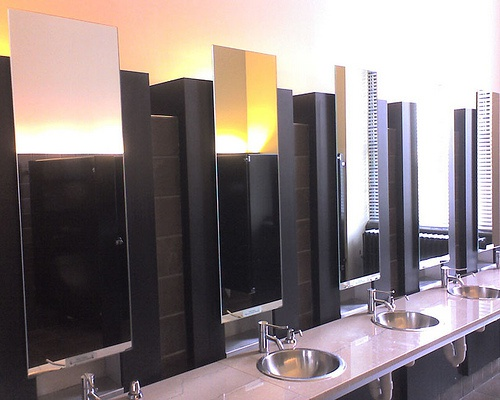Describe the objects in this image and their specific colors. I can see sink in tan, gray, lavender, and darkgray tones, sink in tan, darkgray, white, and gray tones, and sink in tan, lavender, darkgray, and gray tones in this image. 